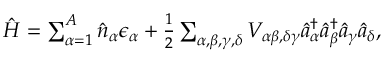<formula> <loc_0><loc_0><loc_500><loc_500>\begin{array} { r } { \hat { H } = \sum _ { \alpha = 1 } ^ { A } \hat { n } _ { \alpha } \epsilon _ { \alpha } + \frac { 1 } { 2 } \sum _ { \alpha , \beta , \gamma , \delta } V _ { \alpha \beta , \delta \gamma } \hat { a } _ { \alpha } ^ { \dagger } \hat { a } _ { \beta } ^ { \dagger } \hat { a } _ { \gamma } \hat { a } _ { \delta } , } \end{array}</formula> 